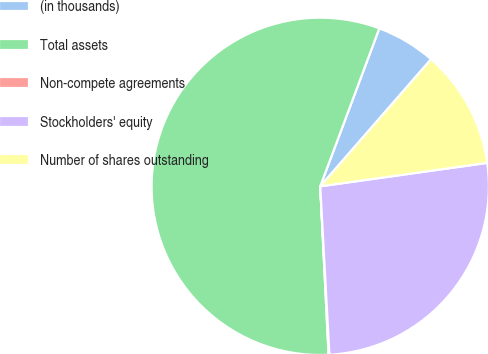Convert chart. <chart><loc_0><loc_0><loc_500><loc_500><pie_chart><fcel>(in thousands)<fcel>Total assets<fcel>Non-compete agreements<fcel>Stockholders' equity<fcel>Number of shares outstanding<nl><fcel>5.72%<fcel>56.48%<fcel>0.08%<fcel>26.35%<fcel>11.36%<nl></chart> 